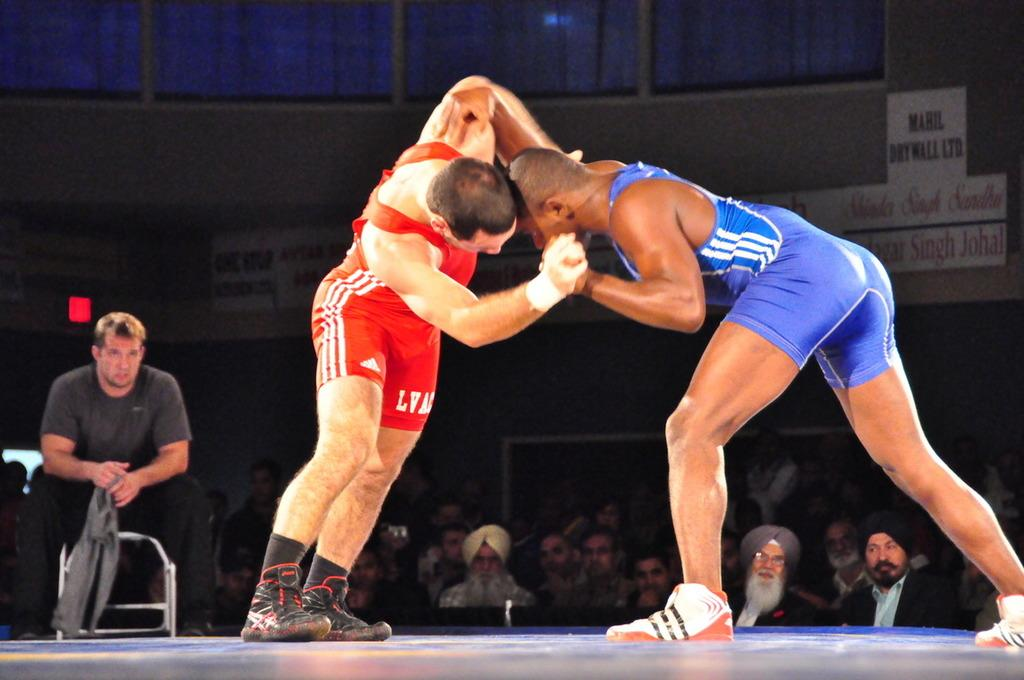Provide a one-sentence caption for the provided image. a pair of shorts that has LVA on it. 